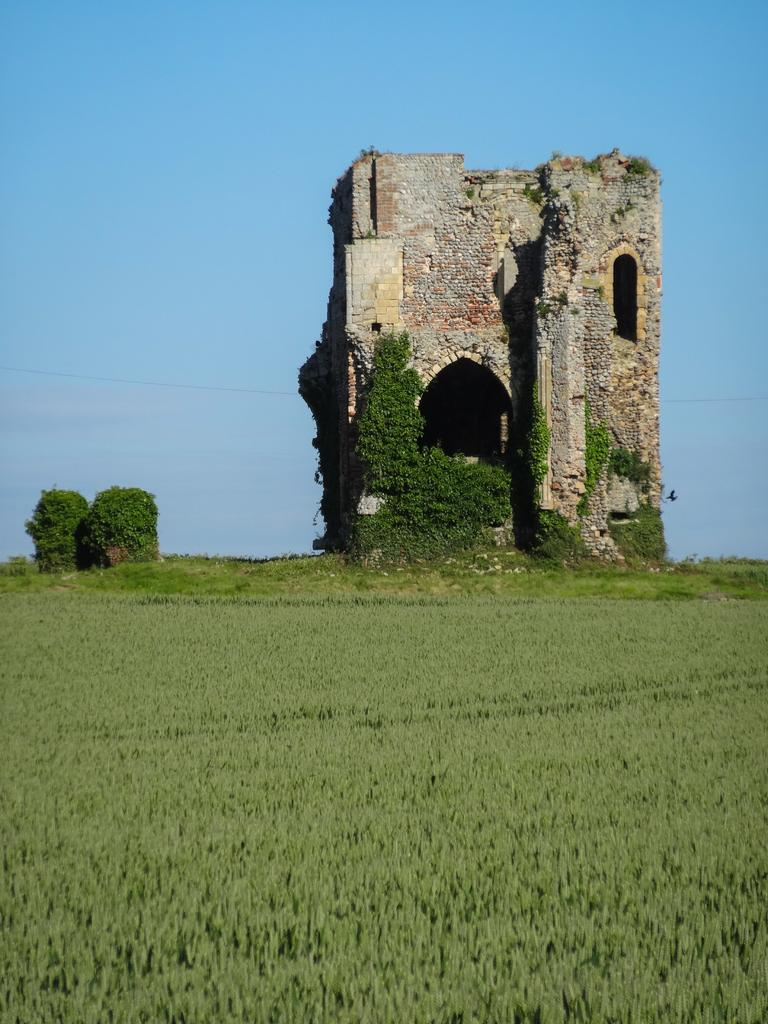What type of structure can be seen in the image? There is a building in the image. What other natural elements are present in the image? There are plants, trees, and a bird visible in the image. Can you describe the wire in the image? There is a wire in the image, but its specific purpose or function is not clear. How would you describe the sky in the image? The sky is visible in the image and appears cloudy. What type of cabbage is being grown in the image? There is no cabbage present in the image; the plants visible are not identified as cabbage. 